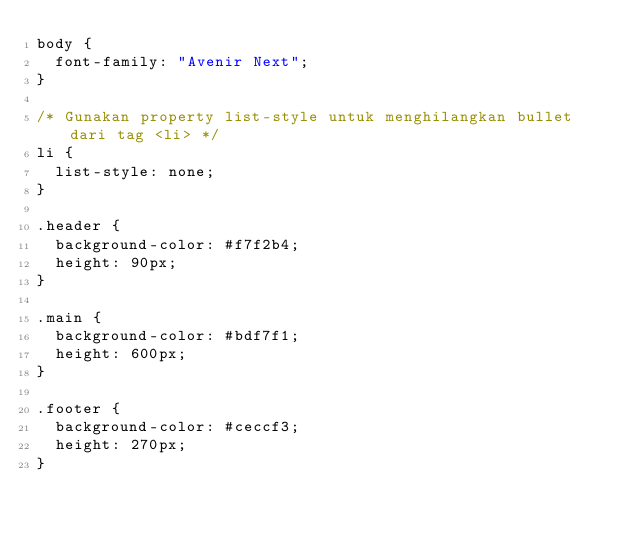<code> <loc_0><loc_0><loc_500><loc_500><_CSS_>body {
  font-family: "Avenir Next";
}

/* Gunakan property list-style untuk menghilangkan bullet dari tag <li> */
li {
  list-style: none;
}

.header {
  background-color: #f7f2b4;
  height: 90px;
}

.main {
  background-color: #bdf7f1;
  height: 600px;
}

.footer {
  background-color: #ceccf3;
  height: 270px;
}</code> 